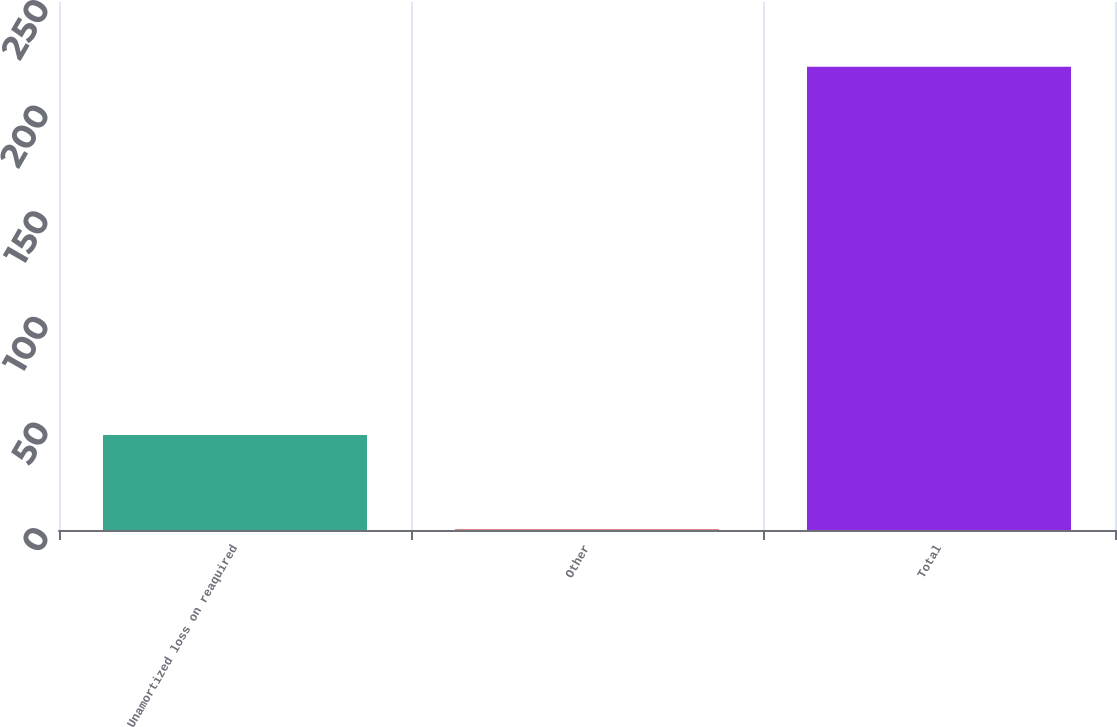<chart> <loc_0><loc_0><loc_500><loc_500><bar_chart><fcel>Unamortized loss on reaquired<fcel>Other<fcel>Total<nl><fcel>45<fcel>0.3<fcel>219.4<nl></chart> 